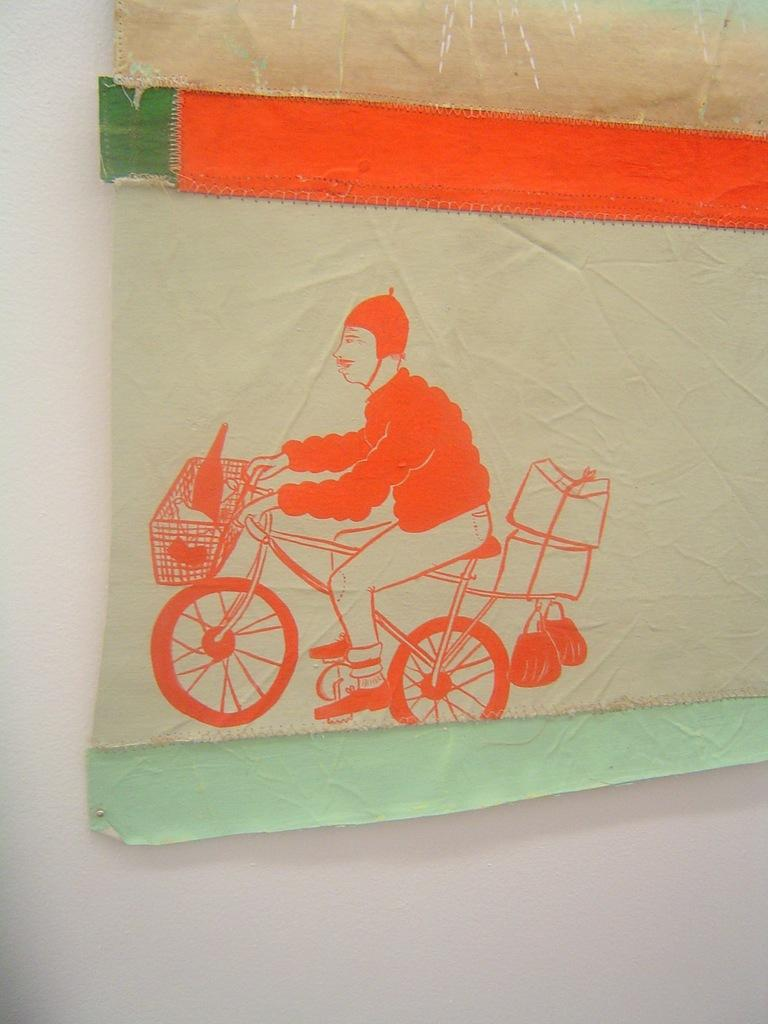What is on the wall in the image? There is a poster on the wall. What is depicted on the poster? The poster features a figure of a person. What is the person doing in the poster? The person is riding a bicycle in the poster. Can you tell me how many girls are holding a liquid-filled faucet in the image? There are no girls or faucets present in the image; it only features a poster with a person riding a bicycle. 